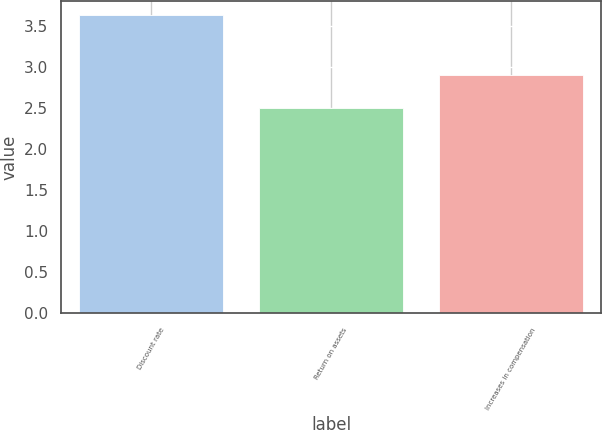<chart> <loc_0><loc_0><loc_500><loc_500><bar_chart><fcel>Discount rate<fcel>Return on assets<fcel>Increases in compensation<nl><fcel>3.63<fcel>2.5<fcel>2.9<nl></chart> 